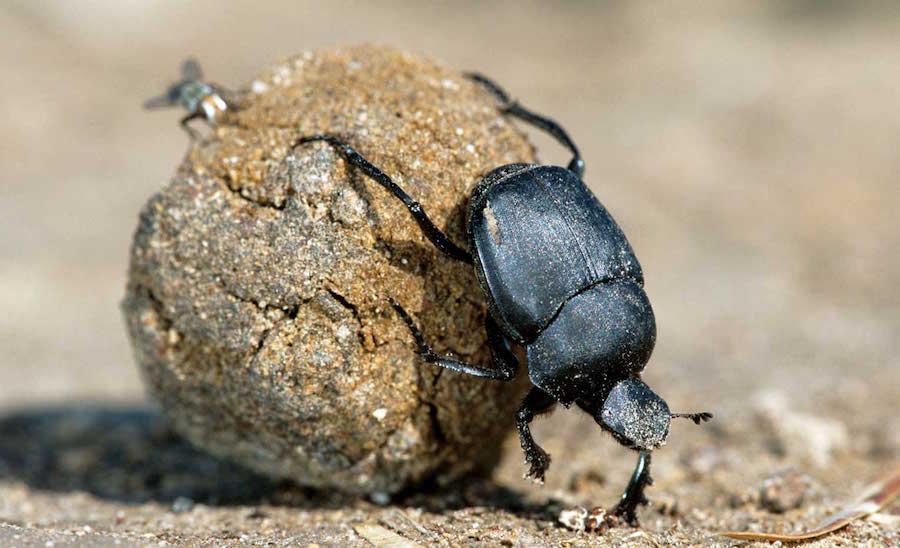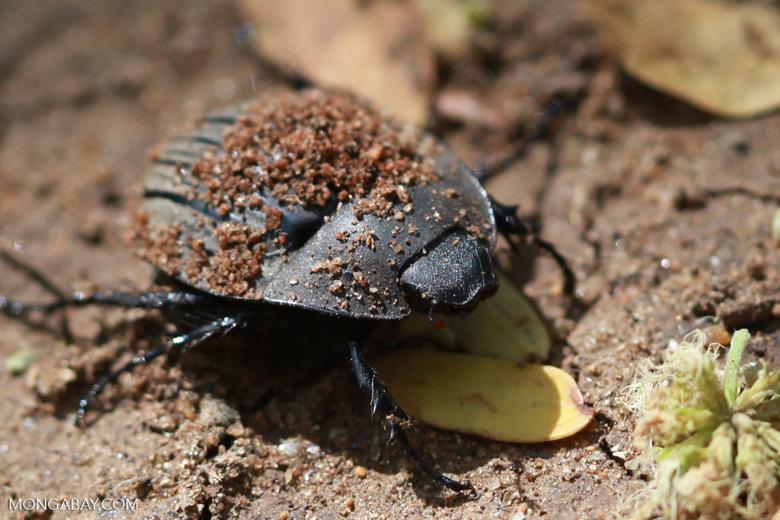The first image is the image on the left, the second image is the image on the right. Examine the images to the left and right. Is the description "there are two dung beetles on a dung ball" accurate? Answer yes or no. No. The first image is the image on the left, the second image is the image on the right. Assess this claim about the two images: "In each of the images only one dung beetle can be seen.". Correct or not? Answer yes or no. Yes. 